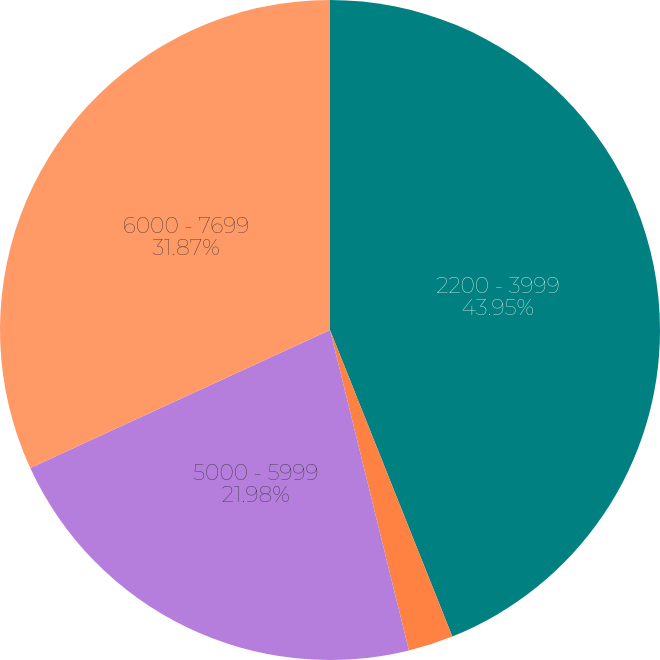<chart> <loc_0><loc_0><loc_500><loc_500><pie_chart><fcel>2200 - 3999<fcel>4000 - 4999<fcel>5000 - 5999<fcel>6000 - 7699<nl><fcel>43.96%<fcel>2.2%<fcel>21.98%<fcel>31.87%<nl></chart> 